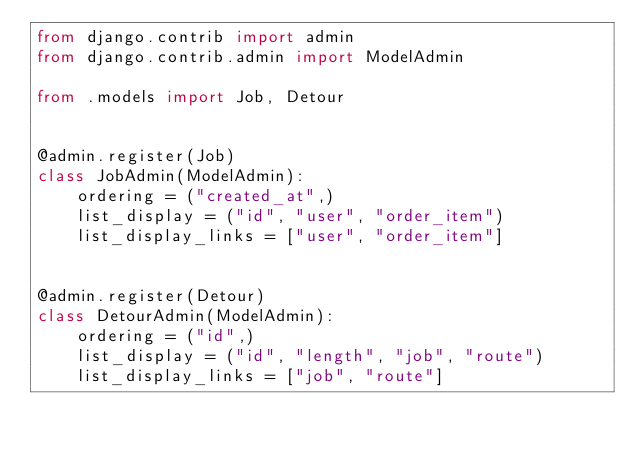<code> <loc_0><loc_0><loc_500><loc_500><_Python_>from django.contrib import admin
from django.contrib.admin import ModelAdmin

from .models import Job, Detour


@admin.register(Job)
class JobAdmin(ModelAdmin):
    ordering = ("created_at",)
    list_display = ("id", "user", "order_item")
    list_display_links = ["user", "order_item"]


@admin.register(Detour)
class DetourAdmin(ModelAdmin):
    ordering = ("id",)
    list_display = ("id", "length", "job", "route")
    list_display_links = ["job", "route"]
</code> 